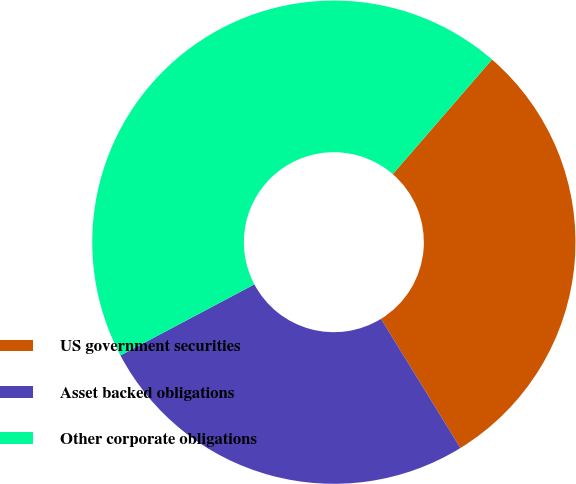Convert chart to OTSL. <chart><loc_0><loc_0><loc_500><loc_500><pie_chart><fcel>US government securities<fcel>Asset backed obligations<fcel>Other corporate obligations<nl><fcel>29.87%<fcel>26.01%<fcel>44.12%<nl></chart> 